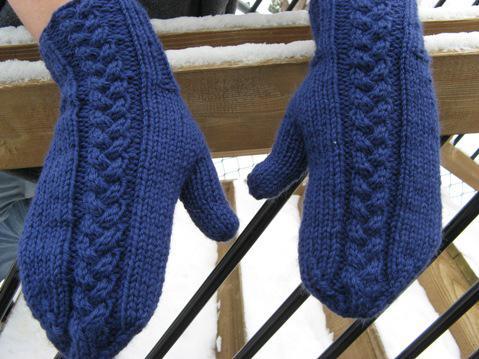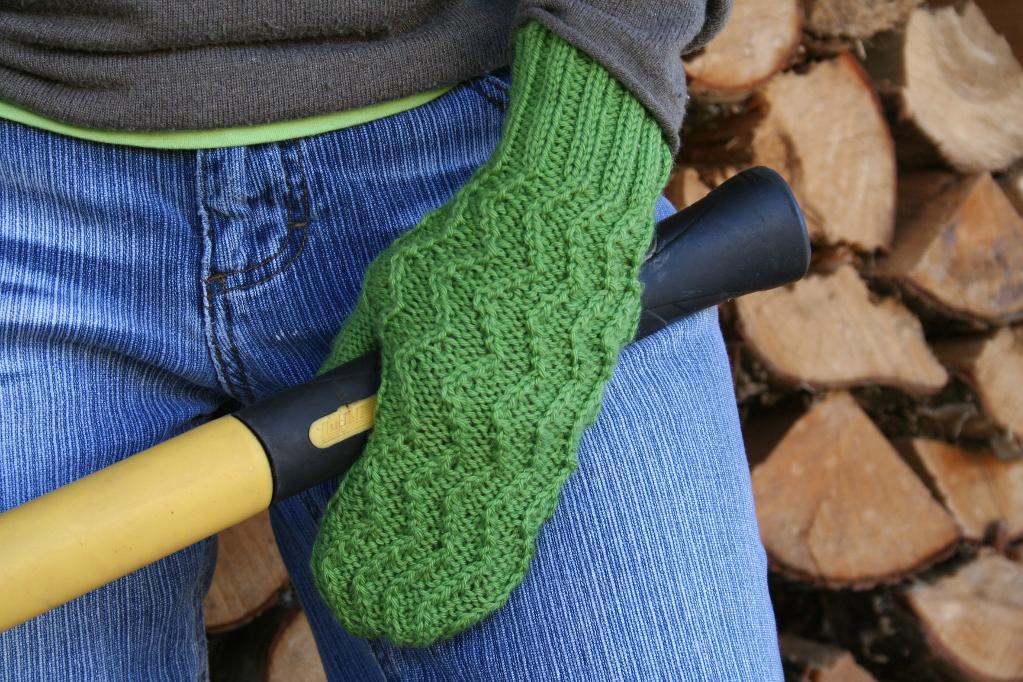The first image is the image on the left, the second image is the image on the right. For the images shown, is this caption "The mittens in the left image are on a pair of human hands." true? Answer yes or no. Yes. The first image is the image on the left, the second image is the image on the right. Examine the images to the left and right. Is the description "One pair of mittens features at least two or more colors in a patterned design." accurate? Answer yes or no. No. 